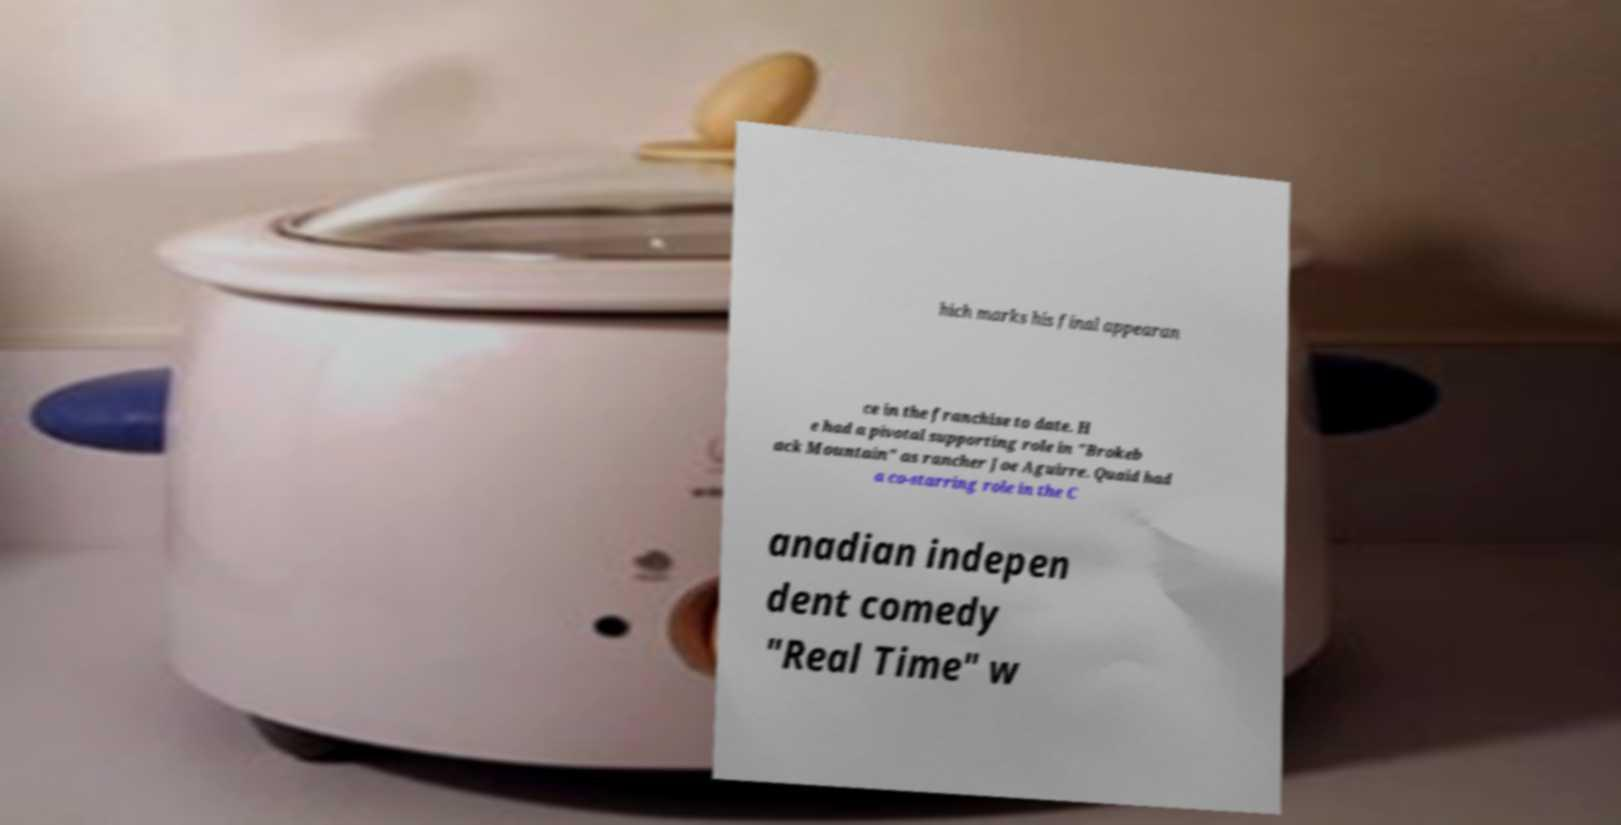I need the written content from this picture converted into text. Can you do that? hich marks his final appearan ce in the franchise to date. H e had a pivotal supporting role in "Brokeb ack Mountain" as rancher Joe Aguirre. Quaid had a co-starring role in the C anadian indepen dent comedy "Real Time" w 